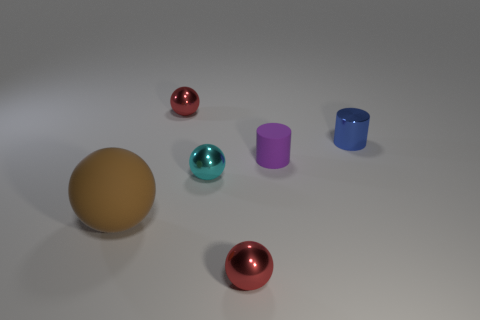Subtract all red balls. How many were subtracted if there are1red balls left? 1 Add 3 small rubber cylinders. How many objects exist? 9 Subtract all cyan metal balls. How many balls are left? 3 Subtract all balls. How many objects are left? 2 Subtract 2 cylinders. How many cylinders are left? 0 Subtract all gray balls. Subtract all brown cylinders. How many balls are left? 4 Subtract all purple cubes. How many purple spheres are left? 0 Subtract all blue cylinders. Subtract all spheres. How many objects are left? 1 Add 3 small shiny cylinders. How many small shiny cylinders are left? 4 Add 1 large green matte things. How many large green matte things exist? 1 